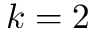Convert formula to latex. <formula><loc_0><loc_0><loc_500><loc_500>k = 2</formula> 